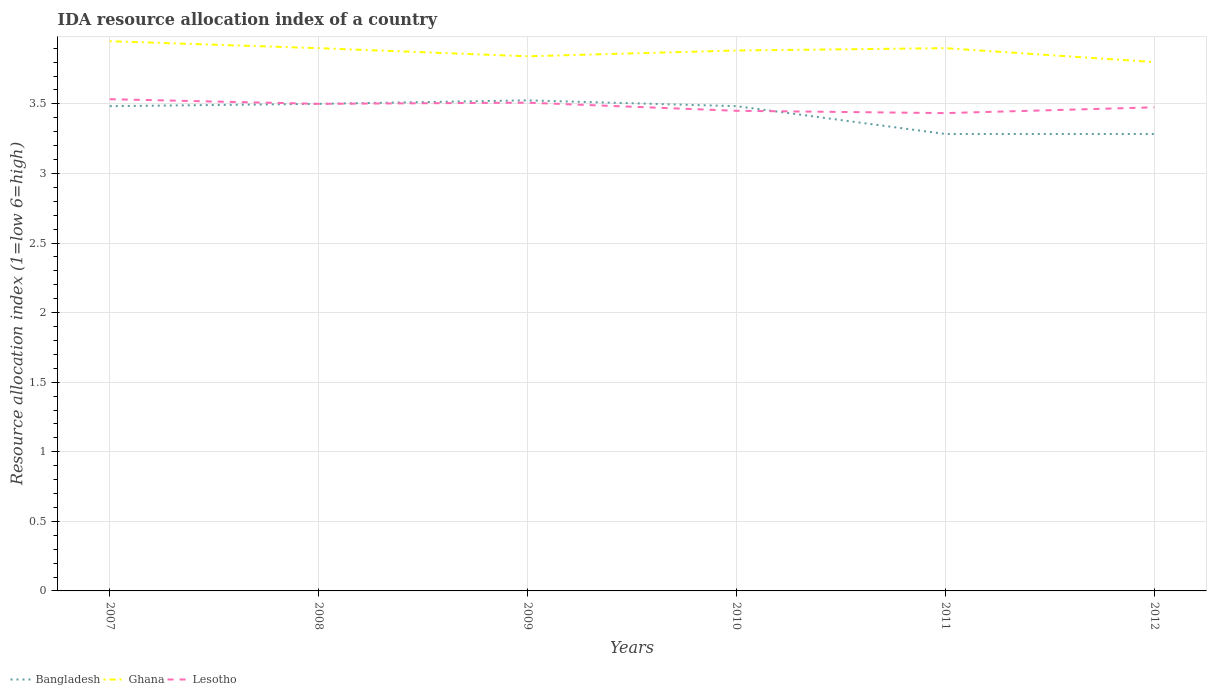Does the line corresponding to Bangladesh intersect with the line corresponding to Ghana?
Your answer should be compact. No. Across all years, what is the maximum IDA resource allocation index in Ghana?
Your answer should be very brief. 3.8. In which year was the IDA resource allocation index in Ghana maximum?
Make the answer very short. 2012. What is the total IDA resource allocation index in Ghana in the graph?
Provide a short and direct response. 0.08. What is the difference between the highest and the second highest IDA resource allocation index in Lesotho?
Your answer should be very brief. 0.1. Does the graph contain any zero values?
Your answer should be very brief. No. Does the graph contain grids?
Keep it short and to the point. Yes. Where does the legend appear in the graph?
Provide a short and direct response. Bottom left. What is the title of the graph?
Your answer should be compact. IDA resource allocation index of a country. What is the label or title of the Y-axis?
Ensure brevity in your answer.  Resource allocation index (1=low 6=high). What is the Resource allocation index (1=low 6=high) in Bangladesh in 2007?
Provide a succinct answer. 3.48. What is the Resource allocation index (1=low 6=high) in Ghana in 2007?
Provide a short and direct response. 3.95. What is the Resource allocation index (1=low 6=high) in Lesotho in 2007?
Your answer should be compact. 3.53. What is the Resource allocation index (1=low 6=high) of Ghana in 2008?
Your response must be concise. 3.9. What is the Resource allocation index (1=low 6=high) of Lesotho in 2008?
Your response must be concise. 3.5. What is the Resource allocation index (1=low 6=high) of Bangladesh in 2009?
Your response must be concise. 3.52. What is the Resource allocation index (1=low 6=high) in Ghana in 2009?
Keep it short and to the point. 3.84. What is the Resource allocation index (1=low 6=high) of Lesotho in 2009?
Make the answer very short. 3.51. What is the Resource allocation index (1=low 6=high) of Bangladesh in 2010?
Your response must be concise. 3.48. What is the Resource allocation index (1=low 6=high) of Ghana in 2010?
Your answer should be compact. 3.88. What is the Resource allocation index (1=low 6=high) in Lesotho in 2010?
Your answer should be compact. 3.45. What is the Resource allocation index (1=low 6=high) in Bangladesh in 2011?
Your answer should be very brief. 3.28. What is the Resource allocation index (1=low 6=high) in Lesotho in 2011?
Give a very brief answer. 3.43. What is the Resource allocation index (1=low 6=high) of Bangladesh in 2012?
Offer a very short reply. 3.28. What is the Resource allocation index (1=low 6=high) of Ghana in 2012?
Ensure brevity in your answer.  3.8. What is the Resource allocation index (1=low 6=high) of Lesotho in 2012?
Your answer should be compact. 3.48. Across all years, what is the maximum Resource allocation index (1=low 6=high) of Bangladesh?
Provide a succinct answer. 3.52. Across all years, what is the maximum Resource allocation index (1=low 6=high) in Ghana?
Offer a very short reply. 3.95. Across all years, what is the maximum Resource allocation index (1=low 6=high) in Lesotho?
Ensure brevity in your answer.  3.53. Across all years, what is the minimum Resource allocation index (1=low 6=high) in Bangladesh?
Offer a very short reply. 3.28. Across all years, what is the minimum Resource allocation index (1=low 6=high) in Ghana?
Give a very brief answer. 3.8. Across all years, what is the minimum Resource allocation index (1=low 6=high) in Lesotho?
Offer a terse response. 3.43. What is the total Resource allocation index (1=low 6=high) of Bangladesh in the graph?
Make the answer very short. 20.56. What is the total Resource allocation index (1=low 6=high) of Ghana in the graph?
Offer a very short reply. 23.27. What is the total Resource allocation index (1=low 6=high) in Lesotho in the graph?
Offer a terse response. 20.9. What is the difference between the Resource allocation index (1=low 6=high) of Bangladesh in 2007 and that in 2008?
Keep it short and to the point. -0.02. What is the difference between the Resource allocation index (1=low 6=high) in Lesotho in 2007 and that in 2008?
Ensure brevity in your answer.  0.03. What is the difference between the Resource allocation index (1=low 6=high) of Bangladesh in 2007 and that in 2009?
Ensure brevity in your answer.  -0.04. What is the difference between the Resource allocation index (1=low 6=high) of Ghana in 2007 and that in 2009?
Make the answer very short. 0.11. What is the difference between the Resource allocation index (1=low 6=high) in Lesotho in 2007 and that in 2009?
Your response must be concise. 0.03. What is the difference between the Resource allocation index (1=low 6=high) in Ghana in 2007 and that in 2010?
Ensure brevity in your answer.  0.07. What is the difference between the Resource allocation index (1=low 6=high) of Lesotho in 2007 and that in 2010?
Offer a very short reply. 0.08. What is the difference between the Resource allocation index (1=low 6=high) in Bangladesh in 2007 and that in 2011?
Ensure brevity in your answer.  0.2. What is the difference between the Resource allocation index (1=low 6=high) in Ghana in 2007 and that in 2011?
Your answer should be compact. 0.05. What is the difference between the Resource allocation index (1=low 6=high) in Bangladesh in 2007 and that in 2012?
Your answer should be very brief. 0.2. What is the difference between the Resource allocation index (1=low 6=high) of Lesotho in 2007 and that in 2012?
Keep it short and to the point. 0.06. What is the difference between the Resource allocation index (1=low 6=high) of Bangladesh in 2008 and that in 2009?
Make the answer very short. -0.03. What is the difference between the Resource allocation index (1=low 6=high) of Ghana in 2008 and that in 2009?
Your response must be concise. 0.06. What is the difference between the Resource allocation index (1=low 6=high) of Lesotho in 2008 and that in 2009?
Offer a terse response. -0.01. What is the difference between the Resource allocation index (1=low 6=high) of Bangladesh in 2008 and that in 2010?
Offer a terse response. 0.02. What is the difference between the Resource allocation index (1=low 6=high) of Ghana in 2008 and that in 2010?
Your response must be concise. 0.02. What is the difference between the Resource allocation index (1=low 6=high) in Bangladesh in 2008 and that in 2011?
Your answer should be very brief. 0.22. What is the difference between the Resource allocation index (1=low 6=high) of Ghana in 2008 and that in 2011?
Your answer should be compact. 0. What is the difference between the Resource allocation index (1=low 6=high) in Lesotho in 2008 and that in 2011?
Your response must be concise. 0.07. What is the difference between the Resource allocation index (1=low 6=high) in Bangladesh in 2008 and that in 2012?
Provide a short and direct response. 0.22. What is the difference between the Resource allocation index (1=low 6=high) of Ghana in 2008 and that in 2012?
Offer a very short reply. 0.1. What is the difference between the Resource allocation index (1=low 6=high) of Lesotho in 2008 and that in 2012?
Offer a terse response. 0.03. What is the difference between the Resource allocation index (1=low 6=high) in Bangladesh in 2009 and that in 2010?
Offer a very short reply. 0.04. What is the difference between the Resource allocation index (1=low 6=high) in Ghana in 2009 and that in 2010?
Your response must be concise. -0.04. What is the difference between the Resource allocation index (1=low 6=high) in Lesotho in 2009 and that in 2010?
Offer a terse response. 0.06. What is the difference between the Resource allocation index (1=low 6=high) of Bangladesh in 2009 and that in 2011?
Make the answer very short. 0.24. What is the difference between the Resource allocation index (1=low 6=high) of Ghana in 2009 and that in 2011?
Provide a short and direct response. -0.06. What is the difference between the Resource allocation index (1=low 6=high) of Lesotho in 2009 and that in 2011?
Your answer should be very brief. 0.07. What is the difference between the Resource allocation index (1=low 6=high) in Bangladesh in 2009 and that in 2012?
Give a very brief answer. 0.24. What is the difference between the Resource allocation index (1=low 6=high) of Ghana in 2009 and that in 2012?
Make the answer very short. 0.04. What is the difference between the Resource allocation index (1=low 6=high) in Ghana in 2010 and that in 2011?
Your answer should be very brief. -0.02. What is the difference between the Resource allocation index (1=low 6=high) in Lesotho in 2010 and that in 2011?
Your answer should be very brief. 0.02. What is the difference between the Resource allocation index (1=low 6=high) in Bangladesh in 2010 and that in 2012?
Offer a terse response. 0.2. What is the difference between the Resource allocation index (1=low 6=high) in Ghana in 2010 and that in 2012?
Provide a short and direct response. 0.08. What is the difference between the Resource allocation index (1=low 6=high) in Lesotho in 2010 and that in 2012?
Give a very brief answer. -0.03. What is the difference between the Resource allocation index (1=low 6=high) of Bangladesh in 2011 and that in 2012?
Your answer should be very brief. 0. What is the difference between the Resource allocation index (1=low 6=high) in Ghana in 2011 and that in 2012?
Offer a very short reply. 0.1. What is the difference between the Resource allocation index (1=low 6=high) of Lesotho in 2011 and that in 2012?
Offer a very short reply. -0.04. What is the difference between the Resource allocation index (1=low 6=high) in Bangladesh in 2007 and the Resource allocation index (1=low 6=high) in Ghana in 2008?
Ensure brevity in your answer.  -0.42. What is the difference between the Resource allocation index (1=low 6=high) in Bangladesh in 2007 and the Resource allocation index (1=low 6=high) in Lesotho in 2008?
Provide a short and direct response. -0.02. What is the difference between the Resource allocation index (1=low 6=high) in Ghana in 2007 and the Resource allocation index (1=low 6=high) in Lesotho in 2008?
Keep it short and to the point. 0.45. What is the difference between the Resource allocation index (1=low 6=high) in Bangladesh in 2007 and the Resource allocation index (1=low 6=high) in Ghana in 2009?
Your response must be concise. -0.36. What is the difference between the Resource allocation index (1=low 6=high) of Bangladesh in 2007 and the Resource allocation index (1=low 6=high) of Lesotho in 2009?
Provide a short and direct response. -0.03. What is the difference between the Resource allocation index (1=low 6=high) of Ghana in 2007 and the Resource allocation index (1=low 6=high) of Lesotho in 2009?
Provide a succinct answer. 0.44. What is the difference between the Resource allocation index (1=low 6=high) of Bangladesh in 2007 and the Resource allocation index (1=low 6=high) of Ghana in 2010?
Ensure brevity in your answer.  -0.4. What is the difference between the Resource allocation index (1=low 6=high) of Ghana in 2007 and the Resource allocation index (1=low 6=high) of Lesotho in 2010?
Your response must be concise. 0.5. What is the difference between the Resource allocation index (1=low 6=high) of Bangladesh in 2007 and the Resource allocation index (1=low 6=high) of Ghana in 2011?
Make the answer very short. -0.42. What is the difference between the Resource allocation index (1=low 6=high) in Bangladesh in 2007 and the Resource allocation index (1=low 6=high) in Lesotho in 2011?
Ensure brevity in your answer.  0.05. What is the difference between the Resource allocation index (1=low 6=high) in Ghana in 2007 and the Resource allocation index (1=low 6=high) in Lesotho in 2011?
Ensure brevity in your answer.  0.52. What is the difference between the Resource allocation index (1=low 6=high) in Bangladesh in 2007 and the Resource allocation index (1=low 6=high) in Ghana in 2012?
Offer a terse response. -0.32. What is the difference between the Resource allocation index (1=low 6=high) in Bangladesh in 2007 and the Resource allocation index (1=low 6=high) in Lesotho in 2012?
Your answer should be compact. 0.01. What is the difference between the Resource allocation index (1=low 6=high) in Ghana in 2007 and the Resource allocation index (1=low 6=high) in Lesotho in 2012?
Make the answer very short. 0.47. What is the difference between the Resource allocation index (1=low 6=high) in Bangladesh in 2008 and the Resource allocation index (1=low 6=high) in Ghana in 2009?
Your response must be concise. -0.34. What is the difference between the Resource allocation index (1=low 6=high) of Bangladesh in 2008 and the Resource allocation index (1=low 6=high) of Lesotho in 2009?
Keep it short and to the point. -0.01. What is the difference between the Resource allocation index (1=low 6=high) of Ghana in 2008 and the Resource allocation index (1=low 6=high) of Lesotho in 2009?
Provide a short and direct response. 0.39. What is the difference between the Resource allocation index (1=low 6=high) in Bangladesh in 2008 and the Resource allocation index (1=low 6=high) in Ghana in 2010?
Give a very brief answer. -0.38. What is the difference between the Resource allocation index (1=low 6=high) in Bangladesh in 2008 and the Resource allocation index (1=low 6=high) in Lesotho in 2010?
Your answer should be very brief. 0.05. What is the difference between the Resource allocation index (1=low 6=high) in Ghana in 2008 and the Resource allocation index (1=low 6=high) in Lesotho in 2010?
Give a very brief answer. 0.45. What is the difference between the Resource allocation index (1=low 6=high) in Bangladesh in 2008 and the Resource allocation index (1=low 6=high) in Ghana in 2011?
Offer a terse response. -0.4. What is the difference between the Resource allocation index (1=low 6=high) in Bangladesh in 2008 and the Resource allocation index (1=low 6=high) in Lesotho in 2011?
Provide a succinct answer. 0.07. What is the difference between the Resource allocation index (1=low 6=high) of Ghana in 2008 and the Resource allocation index (1=low 6=high) of Lesotho in 2011?
Offer a terse response. 0.47. What is the difference between the Resource allocation index (1=low 6=high) of Bangladesh in 2008 and the Resource allocation index (1=low 6=high) of Lesotho in 2012?
Provide a succinct answer. 0.03. What is the difference between the Resource allocation index (1=low 6=high) of Ghana in 2008 and the Resource allocation index (1=low 6=high) of Lesotho in 2012?
Your response must be concise. 0.42. What is the difference between the Resource allocation index (1=low 6=high) of Bangladesh in 2009 and the Resource allocation index (1=low 6=high) of Ghana in 2010?
Provide a succinct answer. -0.36. What is the difference between the Resource allocation index (1=low 6=high) of Bangladesh in 2009 and the Resource allocation index (1=low 6=high) of Lesotho in 2010?
Your answer should be compact. 0.07. What is the difference between the Resource allocation index (1=low 6=high) of Ghana in 2009 and the Resource allocation index (1=low 6=high) of Lesotho in 2010?
Provide a short and direct response. 0.39. What is the difference between the Resource allocation index (1=low 6=high) of Bangladesh in 2009 and the Resource allocation index (1=low 6=high) of Ghana in 2011?
Your answer should be very brief. -0.38. What is the difference between the Resource allocation index (1=low 6=high) of Bangladesh in 2009 and the Resource allocation index (1=low 6=high) of Lesotho in 2011?
Give a very brief answer. 0.09. What is the difference between the Resource allocation index (1=low 6=high) of Ghana in 2009 and the Resource allocation index (1=low 6=high) of Lesotho in 2011?
Give a very brief answer. 0.41. What is the difference between the Resource allocation index (1=low 6=high) in Bangladesh in 2009 and the Resource allocation index (1=low 6=high) in Ghana in 2012?
Keep it short and to the point. -0.28. What is the difference between the Resource allocation index (1=low 6=high) of Ghana in 2009 and the Resource allocation index (1=low 6=high) of Lesotho in 2012?
Your response must be concise. 0.37. What is the difference between the Resource allocation index (1=low 6=high) in Bangladesh in 2010 and the Resource allocation index (1=low 6=high) in Ghana in 2011?
Your answer should be compact. -0.42. What is the difference between the Resource allocation index (1=low 6=high) of Ghana in 2010 and the Resource allocation index (1=low 6=high) of Lesotho in 2011?
Make the answer very short. 0.45. What is the difference between the Resource allocation index (1=low 6=high) in Bangladesh in 2010 and the Resource allocation index (1=low 6=high) in Ghana in 2012?
Your response must be concise. -0.32. What is the difference between the Resource allocation index (1=low 6=high) of Bangladesh in 2010 and the Resource allocation index (1=low 6=high) of Lesotho in 2012?
Your response must be concise. 0.01. What is the difference between the Resource allocation index (1=low 6=high) in Ghana in 2010 and the Resource allocation index (1=low 6=high) in Lesotho in 2012?
Provide a succinct answer. 0.41. What is the difference between the Resource allocation index (1=low 6=high) in Bangladesh in 2011 and the Resource allocation index (1=low 6=high) in Ghana in 2012?
Make the answer very short. -0.52. What is the difference between the Resource allocation index (1=low 6=high) of Bangladesh in 2011 and the Resource allocation index (1=low 6=high) of Lesotho in 2012?
Provide a succinct answer. -0.19. What is the difference between the Resource allocation index (1=low 6=high) of Ghana in 2011 and the Resource allocation index (1=low 6=high) of Lesotho in 2012?
Ensure brevity in your answer.  0.42. What is the average Resource allocation index (1=low 6=high) in Bangladesh per year?
Offer a very short reply. 3.43. What is the average Resource allocation index (1=low 6=high) in Ghana per year?
Offer a very short reply. 3.88. What is the average Resource allocation index (1=low 6=high) in Lesotho per year?
Provide a succinct answer. 3.48. In the year 2007, what is the difference between the Resource allocation index (1=low 6=high) of Bangladesh and Resource allocation index (1=low 6=high) of Ghana?
Offer a terse response. -0.47. In the year 2007, what is the difference between the Resource allocation index (1=low 6=high) in Ghana and Resource allocation index (1=low 6=high) in Lesotho?
Give a very brief answer. 0.42. In the year 2008, what is the difference between the Resource allocation index (1=low 6=high) in Bangladesh and Resource allocation index (1=low 6=high) in Lesotho?
Your response must be concise. 0. In the year 2008, what is the difference between the Resource allocation index (1=low 6=high) in Ghana and Resource allocation index (1=low 6=high) in Lesotho?
Your answer should be compact. 0.4. In the year 2009, what is the difference between the Resource allocation index (1=low 6=high) of Bangladesh and Resource allocation index (1=low 6=high) of Ghana?
Offer a very short reply. -0.32. In the year 2009, what is the difference between the Resource allocation index (1=low 6=high) in Bangladesh and Resource allocation index (1=low 6=high) in Lesotho?
Ensure brevity in your answer.  0.02. In the year 2009, what is the difference between the Resource allocation index (1=low 6=high) in Ghana and Resource allocation index (1=low 6=high) in Lesotho?
Ensure brevity in your answer.  0.33. In the year 2010, what is the difference between the Resource allocation index (1=low 6=high) in Bangladesh and Resource allocation index (1=low 6=high) in Ghana?
Provide a short and direct response. -0.4. In the year 2010, what is the difference between the Resource allocation index (1=low 6=high) of Ghana and Resource allocation index (1=low 6=high) of Lesotho?
Offer a very short reply. 0.43. In the year 2011, what is the difference between the Resource allocation index (1=low 6=high) of Bangladesh and Resource allocation index (1=low 6=high) of Ghana?
Give a very brief answer. -0.62. In the year 2011, what is the difference between the Resource allocation index (1=low 6=high) in Bangladesh and Resource allocation index (1=low 6=high) in Lesotho?
Your response must be concise. -0.15. In the year 2011, what is the difference between the Resource allocation index (1=low 6=high) in Ghana and Resource allocation index (1=low 6=high) in Lesotho?
Your response must be concise. 0.47. In the year 2012, what is the difference between the Resource allocation index (1=low 6=high) of Bangladesh and Resource allocation index (1=low 6=high) of Ghana?
Ensure brevity in your answer.  -0.52. In the year 2012, what is the difference between the Resource allocation index (1=low 6=high) in Bangladesh and Resource allocation index (1=low 6=high) in Lesotho?
Make the answer very short. -0.19. In the year 2012, what is the difference between the Resource allocation index (1=low 6=high) of Ghana and Resource allocation index (1=low 6=high) of Lesotho?
Make the answer very short. 0.33. What is the ratio of the Resource allocation index (1=low 6=high) in Ghana in 2007 to that in 2008?
Your answer should be very brief. 1.01. What is the ratio of the Resource allocation index (1=low 6=high) in Lesotho in 2007 to that in 2008?
Your response must be concise. 1.01. What is the ratio of the Resource allocation index (1=low 6=high) of Ghana in 2007 to that in 2009?
Give a very brief answer. 1.03. What is the ratio of the Resource allocation index (1=low 6=high) in Lesotho in 2007 to that in 2009?
Your answer should be very brief. 1.01. What is the ratio of the Resource allocation index (1=low 6=high) of Ghana in 2007 to that in 2010?
Give a very brief answer. 1.02. What is the ratio of the Resource allocation index (1=low 6=high) of Lesotho in 2007 to that in 2010?
Offer a terse response. 1.02. What is the ratio of the Resource allocation index (1=low 6=high) in Bangladesh in 2007 to that in 2011?
Offer a terse response. 1.06. What is the ratio of the Resource allocation index (1=low 6=high) in Ghana in 2007 to that in 2011?
Give a very brief answer. 1.01. What is the ratio of the Resource allocation index (1=low 6=high) in Lesotho in 2007 to that in 2011?
Your response must be concise. 1.03. What is the ratio of the Resource allocation index (1=low 6=high) of Bangladesh in 2007 to that in 2012?
Your response must be concise. 1.06. What is the ratio of the Resource allocation index (1=low 6=high) of Ghana in 2007 to that in 2012?
Offer a terse response. 1.04. What is the ratio of the Resource allocation index (1=low 6=high) in Lesotho in 2007 to that in 2012?
Offer a very short reply. 1.02. What is the ratio of the Resource allocation index (1=low 6=high) of Ghana in 2008 to that in 2009?
Your answer should be compact. 1.02. What is the ratio of the Resource allocation index (1=low 6=high) of Lesotho in 2008 to that in 2009?
Make the answer very short. 1. What is the ratio of the Resource allocation index (1=low 6=high) of Bangladesh in 2008 to that in 2010?
Offer a very short reply. 1. What is the ratio of the Resource allocation index (1=low 6=high) of Ghana in 2008 to that in 2010?
Ensure brevity in your answer.  1. What is the ratio of the Resource allocation index (1=low 6=high) of Lesotho in 2008 to that in 2010?
Your response must be concise. 1.01. What is the ratio of the Resource allocation index (1=low 6=high) of Bangladesh in 2008 to that in 2011?
Your answer should be compact. 1.07. What is the ratio of the Resource allocation index (1=low 6=high) in Lesotho in 2008 to that in 2011?
Your response must be concise. 1.02. What is the ratio of the Resource allocation index (1=low 6=high) in Bangladesh in 2008 to that in 2012?
Provide a succinct answer. 1.07. What is the ratio of the Resource allocation index (1=low 6=high) of Ghana in 2008 to that in 2012?
Make the answer very short. 1.03. What is the ratio of the Resource allocation index (1=low 6=high) of Bangladesh in 2009 to that in 2010?
Provide a short and direct response. 1.01. What is the ratio of the Resource allocation index (1=low 6=high) of Ghana in 2009 to that in 2010?
Make the answer very short. 0.99. What is the ratio of the Resource allocation index (1=low 6=high) in Lesotho in 2009 to that in 2010?
Provide a short and direct response. 1.02. What is the ratio of the Resource allocation index (1=low 6=high) of Bangladesh in 2009 to that in 2011?
Ensure brevity in your answer.  1.07. What is the ratio of the Resource allocation index (1=low 6=high) in Lesotho in 2009 to that in 2011?
Keep it short and to the point. 1.02. What is the ratio of the Resource allocation index (1=low 6=high) in Bangladesh in 2009 to that in 2012?
Keep it short and to the point. 1.07. What is the ratio of the Resource allocation index (1=low 6=high) of Ghana in 2009 to that in 2012?
Offer a terse response. 1.01. What is the ratio of the Resource allocation index (1=low 6=high) in Lesotho in 2009 to that in 2012?
Offer a terse response. 1.01. What is the ratio of the Resource allocation index (1=low 6=high) in Bangladesh in 2010 to that in 2011?
Your answer should be compact. 1.06. What is the ratio of the Resource allocation index (1=low 6=high) of Bangladesh in 2010 to that in 2012?
Provide a succinct answer. 1.06. What is the ratio of the Resource allocation index (1=low 6=high) of Ghana in 2010 to that in 2012?
Keep it short and to the point. 1.02. What is the ratio of the Resource allocation index (1=low 6=high) in Lesotho in 2010 to that in 2012?
Keep it short and to the point. 0.99. What is the ratio of the Resource allocation index (1=low 6=high) of Bangladesh in 2011 to that in 2012?
Your response must be concise. 1. What is the ratio of the Resource allocation index (1=low 6=high) of Ghana in 2011 to that in 2012?
Make the answer very short. 1.03. What is the difference between the highest and the second highest Resource allocation index (1=low 6=high) of Bangladesh?
Ensure brevity in your answer.  0.03. What is the difference between the highest and the second highest Resource allocation index (1=low 6=high) in Lesotho?
Ensure brevity in your answer.  0.03. What is the difference between the highest and the lowest Resource allocation index (1=low 6=high) of Bangladesh?
Your answer should be compact. 0.24. What is the difference between the highest and the lowest Resource allocation index (1=low 6=high) of Ghana?
Ensure brevity in your answer.  0.15. What is the difference between the highest and the lowest Resource allocation index (1=low 6=high) in Lesotho?
Offer a terse response. 0.1. 